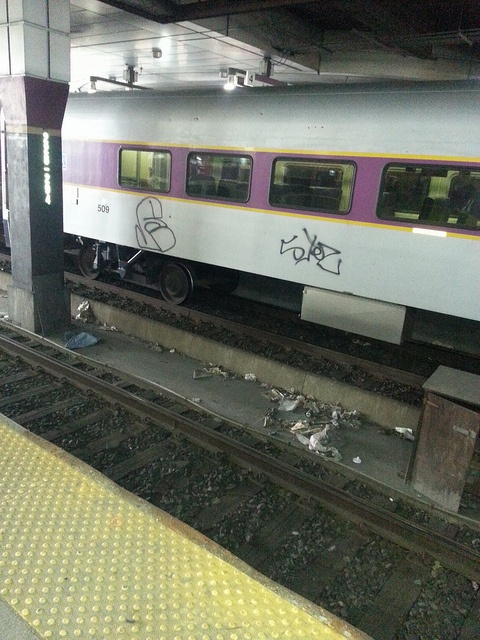Describe the objects in this image and their specific colors. I can see a train in lightgray, darkgray, gray, and black tones in this image. 